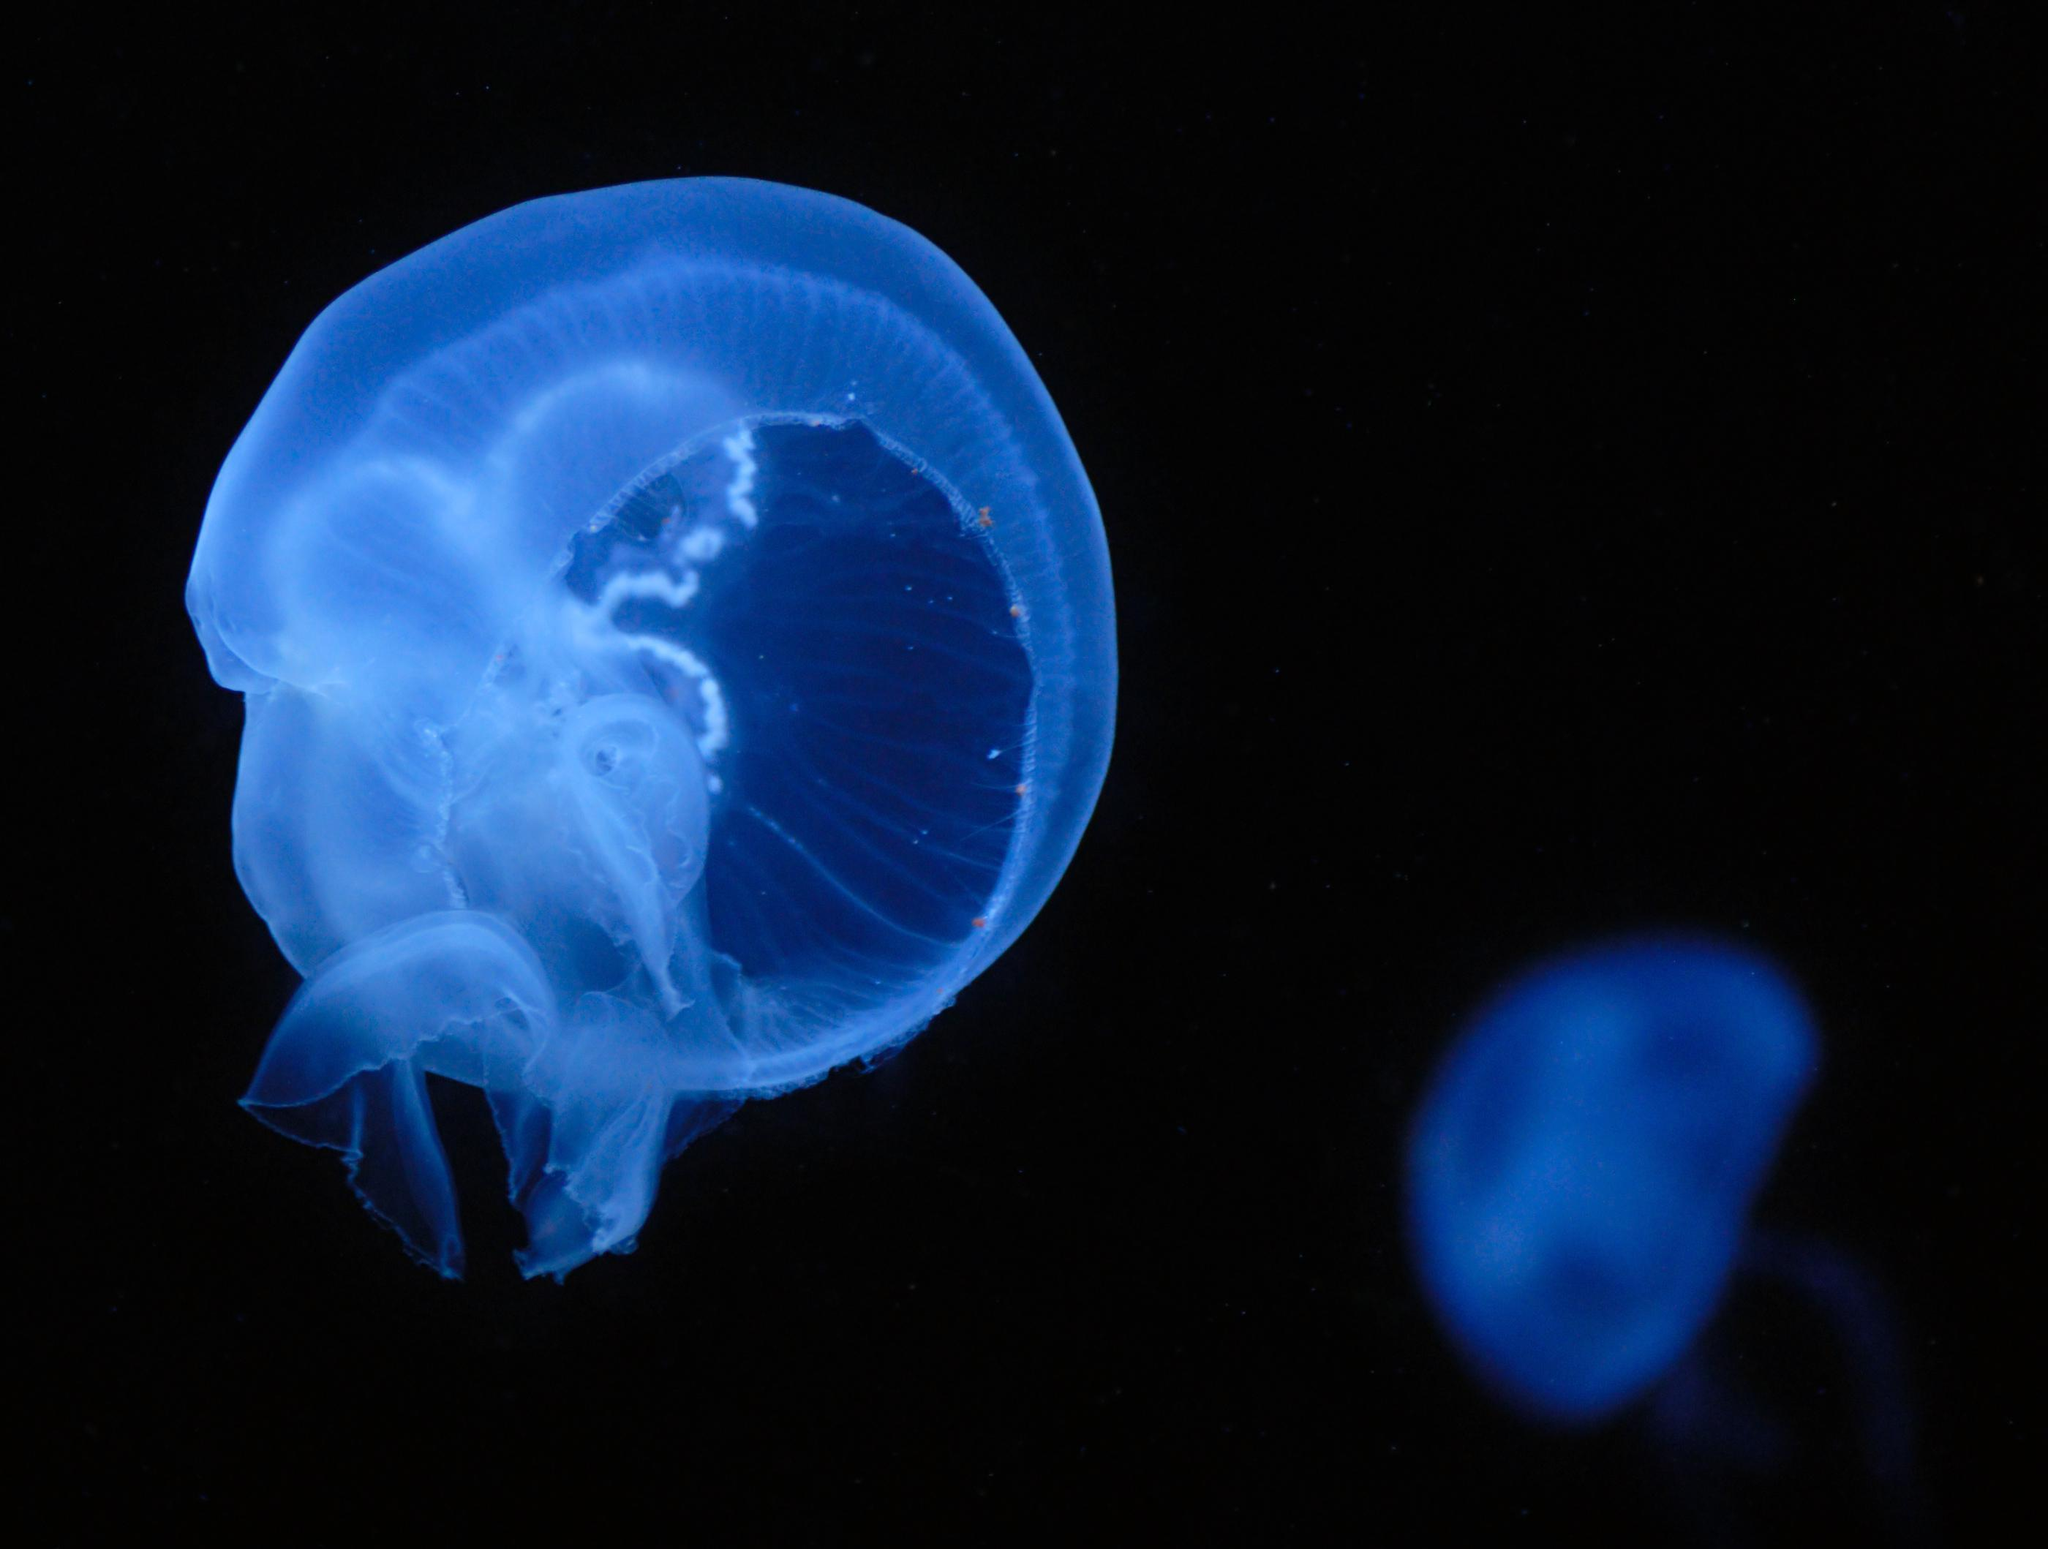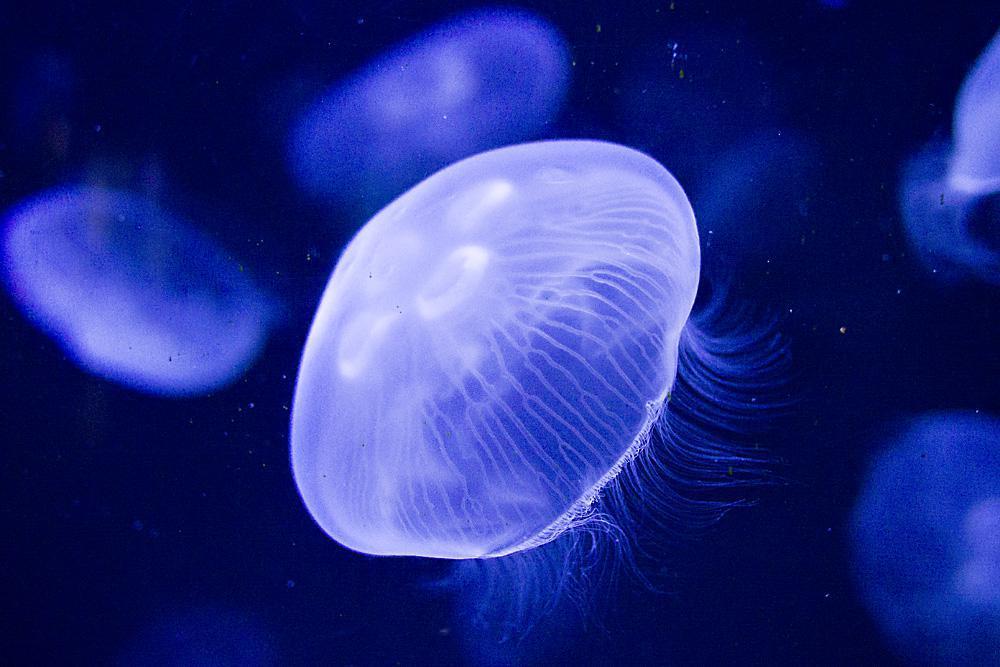The first image is the image on the left, the second image is the image on the right. For the images displayed, is the sentence "the right image has a lone jellyfish swimming to the left" factually correct? Answer yes or no. No. The first image is the image on the left, the second image is the image on the right. Considering the images on both sides, is "There are a total of 2 jelly fish." valid? Answer yes or no. No. 